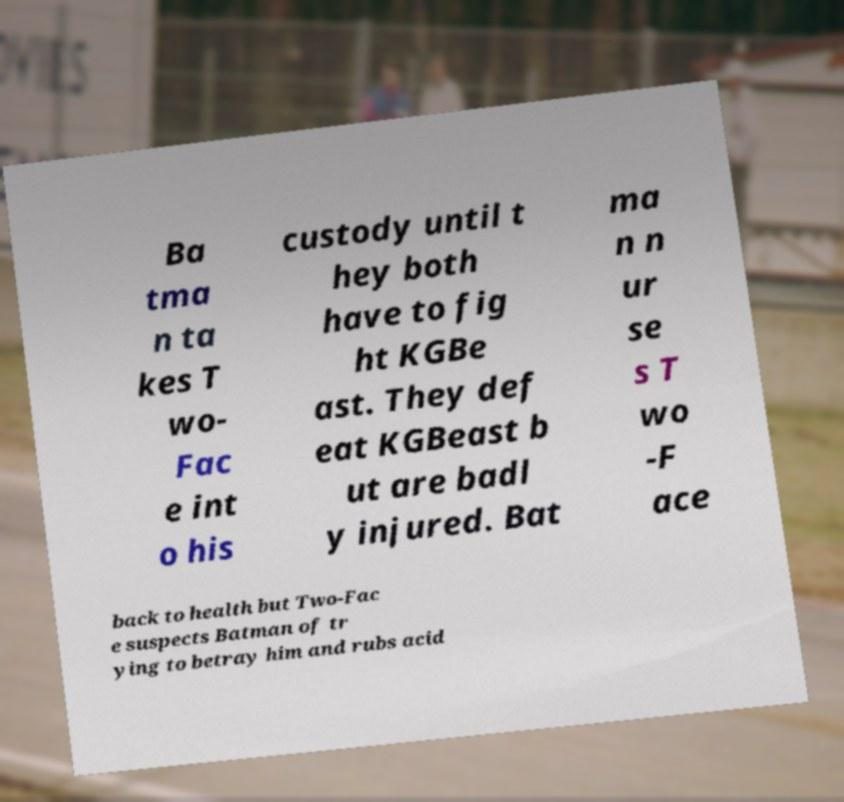What messages or text are displayed in this image? I need them in a readable, typed format. Ba tma n ta kes T wo- Fac e int o his custody until t hey both have to fig ht KGBe ast. They def eat KGBeast b ut are badl y injured. Bat ma n n ur se s T wo -F ace back to health but Two-Fac e suspects Batman of tr ying to betray him and rubs acid 